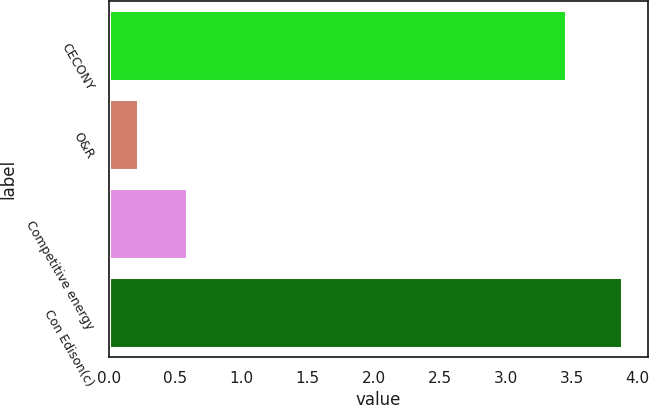Convert chart. <chart><loc_0><loc_0><loc_500><loc_500><bar_chart><fcel>CECONY<fcel>O&R<fcel>Competitive energy<fcel>Con Edison(c)<nl><fcel>3.46<fcel>0.22<fcel>0.59<fcel>3.88<nl></chart> 